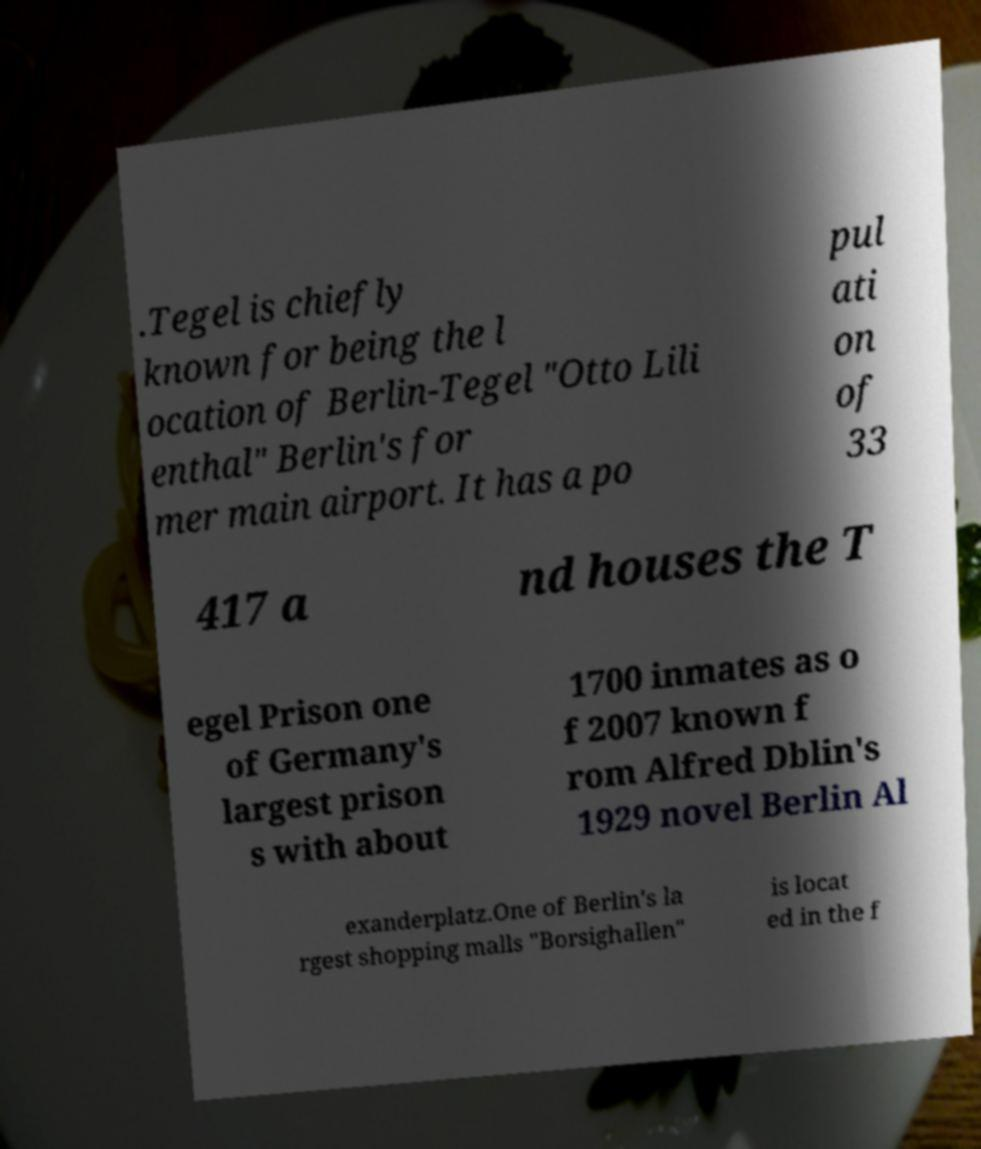For documentation purposes, I need the text within this image transcribed. Could you provide that? .Tegel is chiefly known for being the l ocation of Berlin-Tegel "Otto Lili enthal" Berlin's for mer main airport. It has a po pul ati on of 33 417 a nd houses the T egel Prison one of Germany's largest prison s with about 1700 inmates as o f 2007 known f rom Alfred Dblin's 1929 novel Berlin Al exanderplatz.One of Berlin's la rgest shopping malls "Borsighallen" is locat ed in the f 